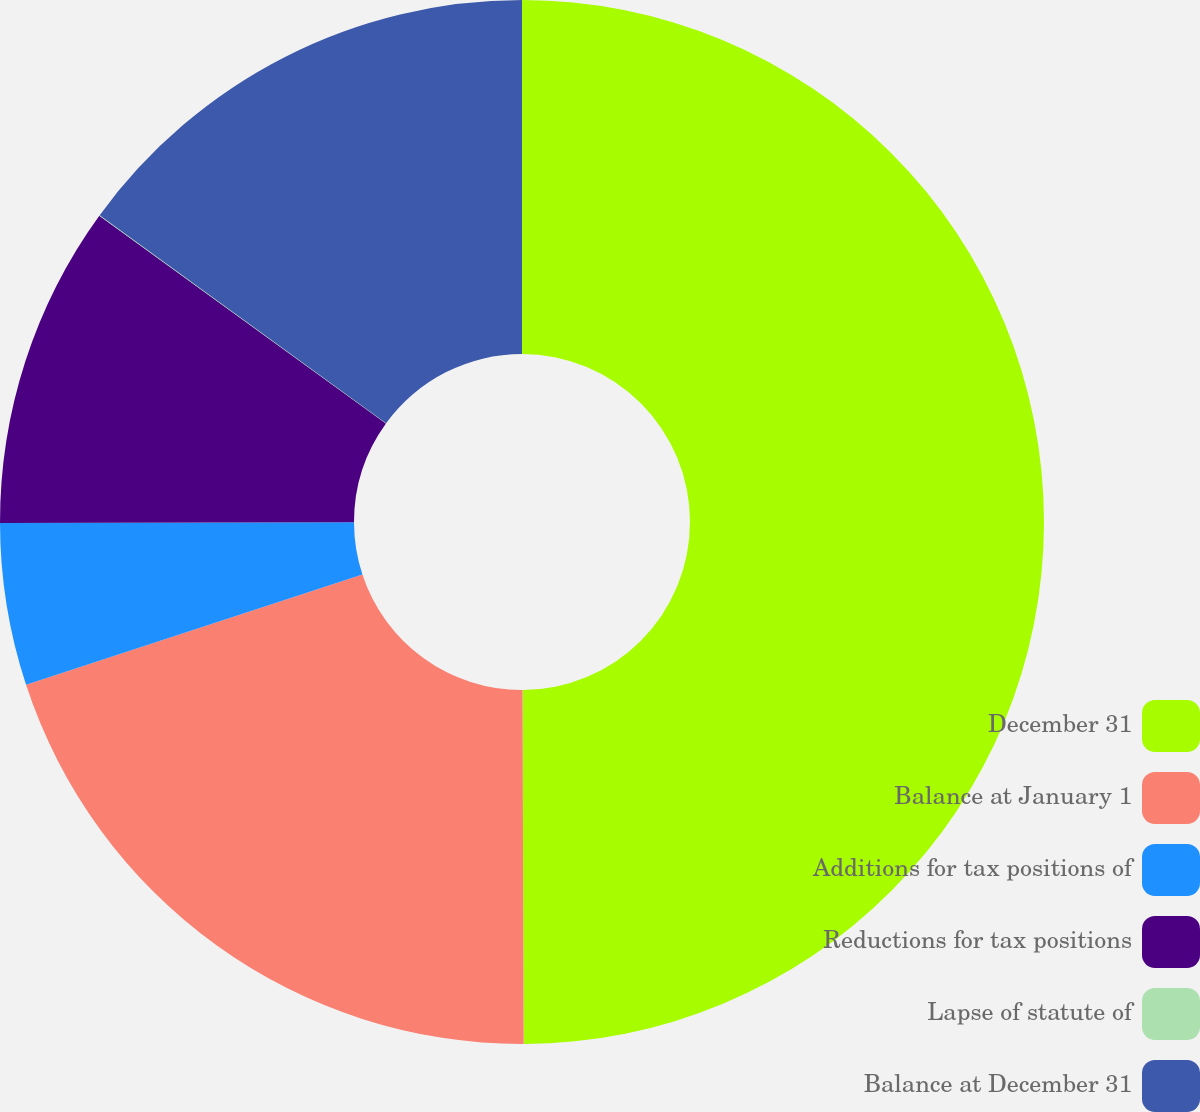Convert chart to OTSL. <chart><loc_0><loc_0><loc_500><loc_500><pie_chart><fcel>December 31<fcel>Balance at January 1<fcel>Additions for tax positions of<fcel>Reductions for tax positions<fcel>Lapse of statute of<fcel>Balance at December 31<nl><fcel>49.95%<fcel>20.0%<fcel>5.02%<fcel>10.01%<fcel>0.02%<fcel>15.0%<nl></chart> 